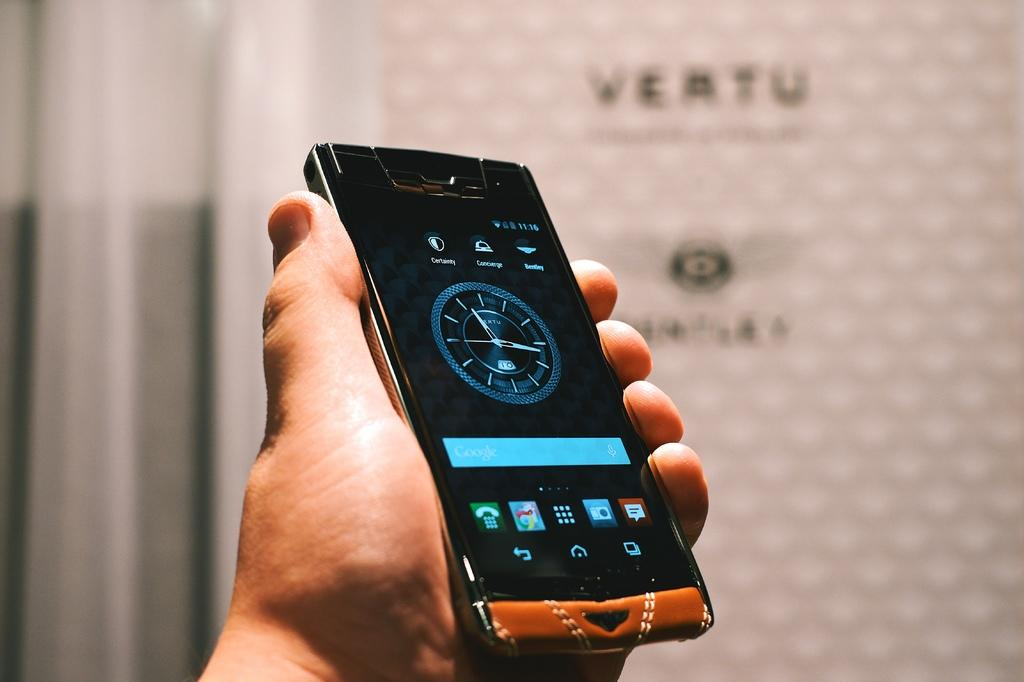<image>
Render a clear and concise summary of the photo. On the screen of a smart phone is a blue, round clock that shows the time. 